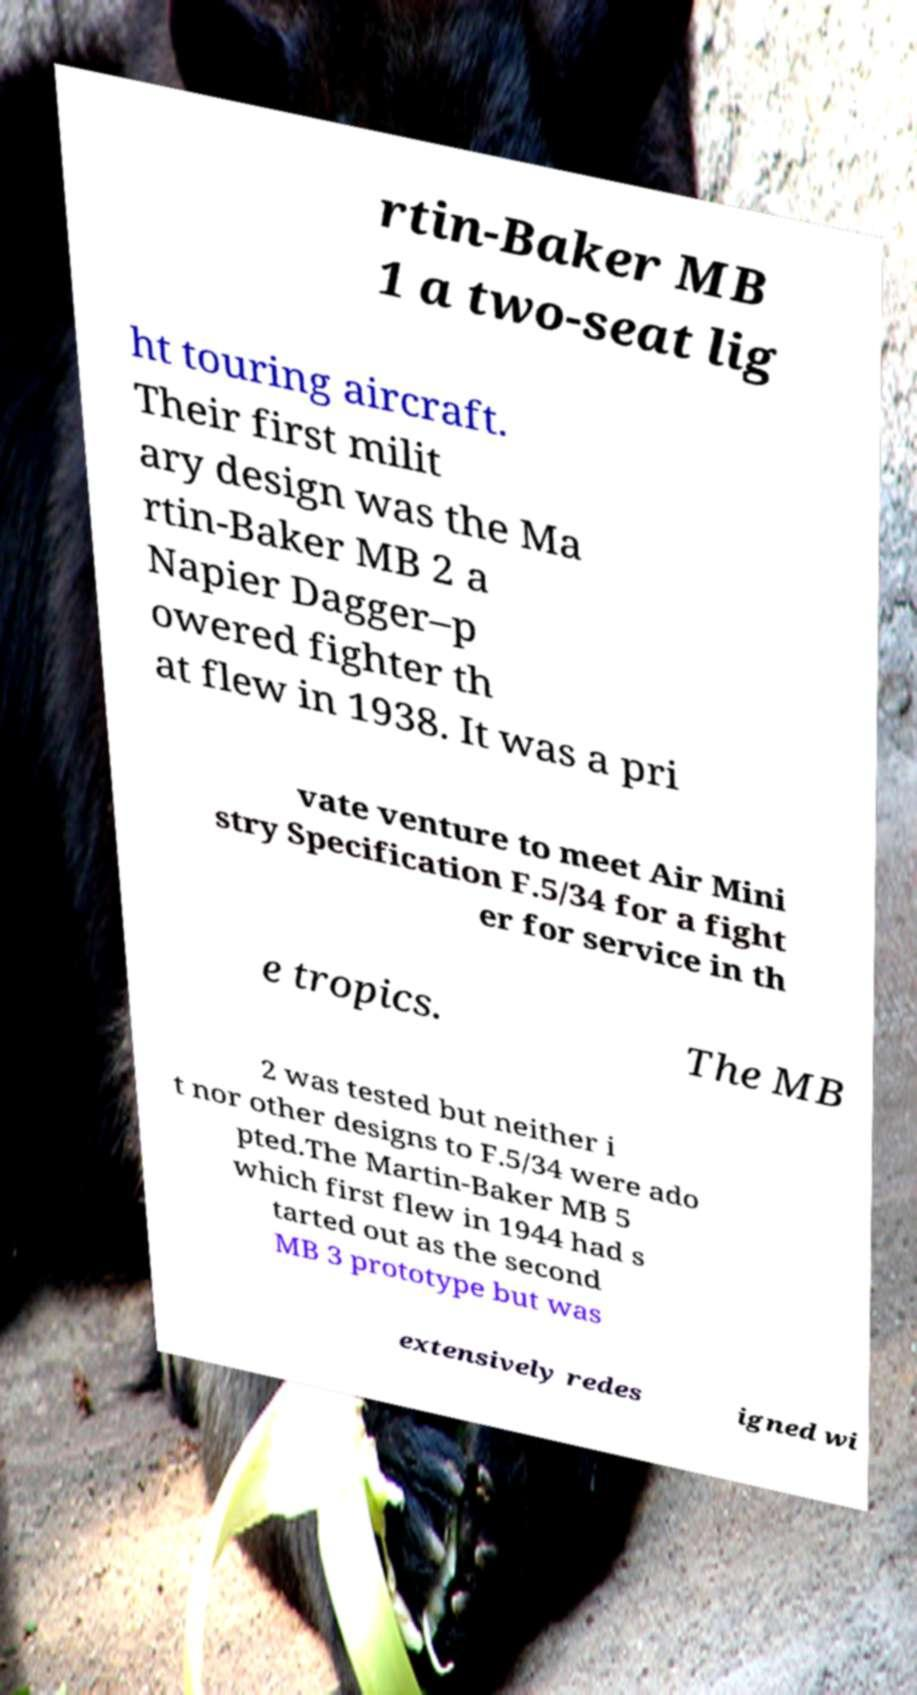Can you accurately transcribe the text from the provided image for me? rtin-Baker MB 1 a two-seat lig ht touring aircraft. Their first milit ary design was the Ma rtin-Baker MB 2 a Napier Dagger–p owered fighter th at flew in 1938. It was a pri vate venture to meet Air Mini stry Specification F.5/34 for a fight er for service in th e tropics. The MB 2 was tested but neither i t nor other designs to F.5/34 were ado pted.The Martin-Baker MB 5 which first flew in 1944 had s tarted out as the second MB 3 prototype but was extensively redes igned wi 